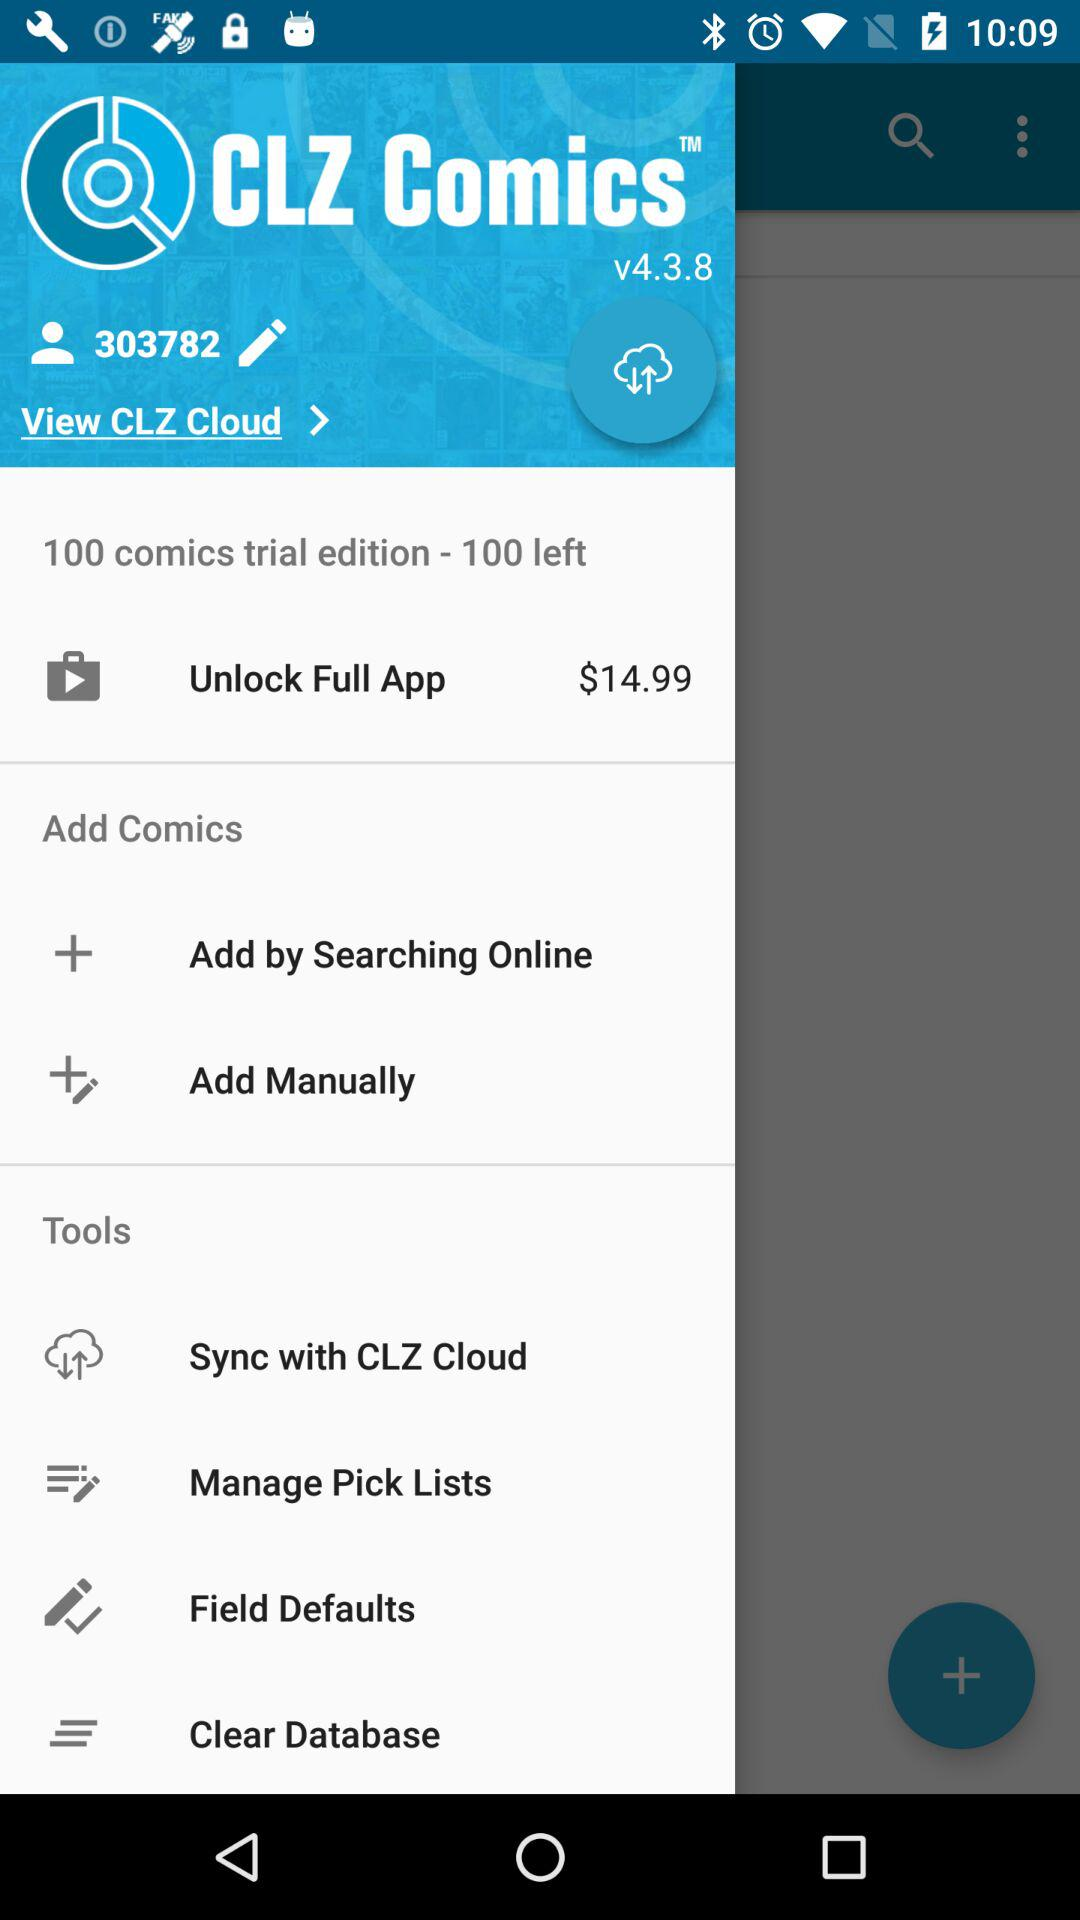How many comics in total are there in the trial edition? There are 100 comics in the trial edition. 